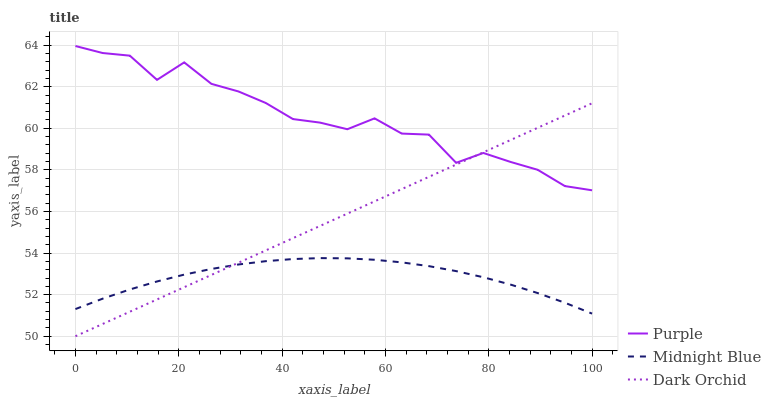Does Midnight Blue have the minimum area under the curve?
Answer yes or no. Yes. Does Purple have the maximum area under the curve?
Answer yes or no. Yes. Does Dark Orchid have the minimum area under the curve?
Answer yes or no. No. Does Dark Orchid have the maximum area under the curve?
Answer yes or no. No. Is Dark Orchid the smoothest?
Answer yes or no. Yes. Is Purple the roughest?
Answer yes or no. Yes. Is Midnight Blue the smoothest?
Answer yes or no. No. Is Midnight Blue the roughest?
Answer yes or no. No. Does Dark Orchid have the lowest value?
Answer yes or no. Yes. Does Midnight Blue have the lowest value?
Answer yes or no. No. Does Purple have the highest value?
Answer yes or no. Yes. Does Dark Orchid have the highest value?
Answer yes or no. No. Is Midnight Blue less than Purple?
Answer yes or no. Yes. Is Purple greater than Midnight Blue?
Answer yes or no. Yes. Does Dark Orchid intersect Purple?
Answer yes or no. Yes. Is Dark Orchid less than Purple?
Answer yes or no. No. Is Dark Orchid greater than Purple?
Answer yes or no. No. Does Midnight Blue intersect Purple?
Answer yes or no. No. 